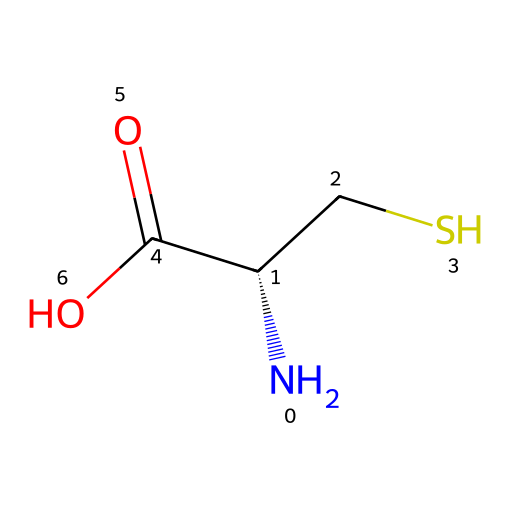What is the name of this amino acid? The SMILES representation indicates the amino acid is L-cysteine due to the presence of the thiol group (CS) and the amino (N) and carboxyl (C(=O)O) functional groups.
Answer: L-cysteine How many carbon atoms are present in L-cysteine? L-cysteine has four carbon atoms: one in the amino group, one in the carboxyl group, and two in the side chain (CS).
Answer: four Is L-cysteine a chiral compound? Yes, L-cysteine is chiral because it has a carbon atom (the one next to the amino group) that is bonded to four different substituents: an amino group, a carboxyl group, a hydrogen atom, and a thiol group.
Answer: yes What functional groups are present in L-cysteine? L-cysteine features three main functional groups: an amino group (NH2), a carboxyl group (COOH), and a thiol group (SH).
Answer: amino, carboxyl, thiol What is the stereochemistry of L-cysteine? The SMILES notation shows [C@@H], indicating that the carbon atom in the chiral center has the S configuration according to Cahn-Ingold-Prelog priority rules.
Answer: S configuration How many hydrogen atoms are bonded to L-cysteine? L-cysteine has seven hydrogen atoms: two from the amino group, one from the chiral carbon, one from the thiol group, and three from the carboxylic acid group.
Answer: seven 